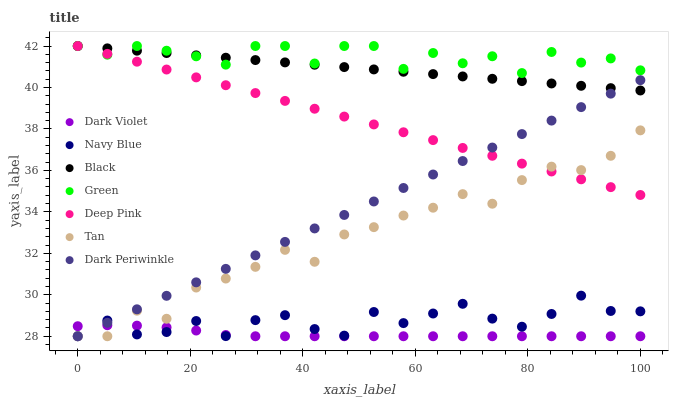Does Dark Violet have the minimum area under the curve?
Answer yes or no. Yes. Does Green have the maximum area under the curve?
Answer yes or no. Yes. Does Navy Blue have the minimum area under the curve?
Answer yes or no. No. Does Navy Blue have the maximum area under the curve?
Answer yes or no. No. Is Deep Pink the smoothest?
Answer yes or no. Yes. Is Green the roughest?
Answer yes or no. Yes. Is Navy Blue the smoothest?
Answer yes or no. No. Is Navy Blue the roughest?
Answer yes or no. No. Does Navy Blue have the lowest value?
Answer yes or no. Yes. Does Green have the lowest value?
Answer yes or no. No. Does Black have the highest value?
Answer yes or no. Yes. Does Navy Blue have the highest value?
Answer yes or no. No. Is Navy Blue less than Black?
Answer yes or no. Yes. Is Deep Pink greater than Dark Violet?
Answer yes or no. Yes. Does Tan intersect Deep Pink?
Answer yes or no. Yes. Is Tan less than Deep Pink?
Answer yes or no. No. Is Tan greater than Deep Pink?
Answer yes or no. No. Does Navy Blue intersect Black?
Answer yes or no. No. 